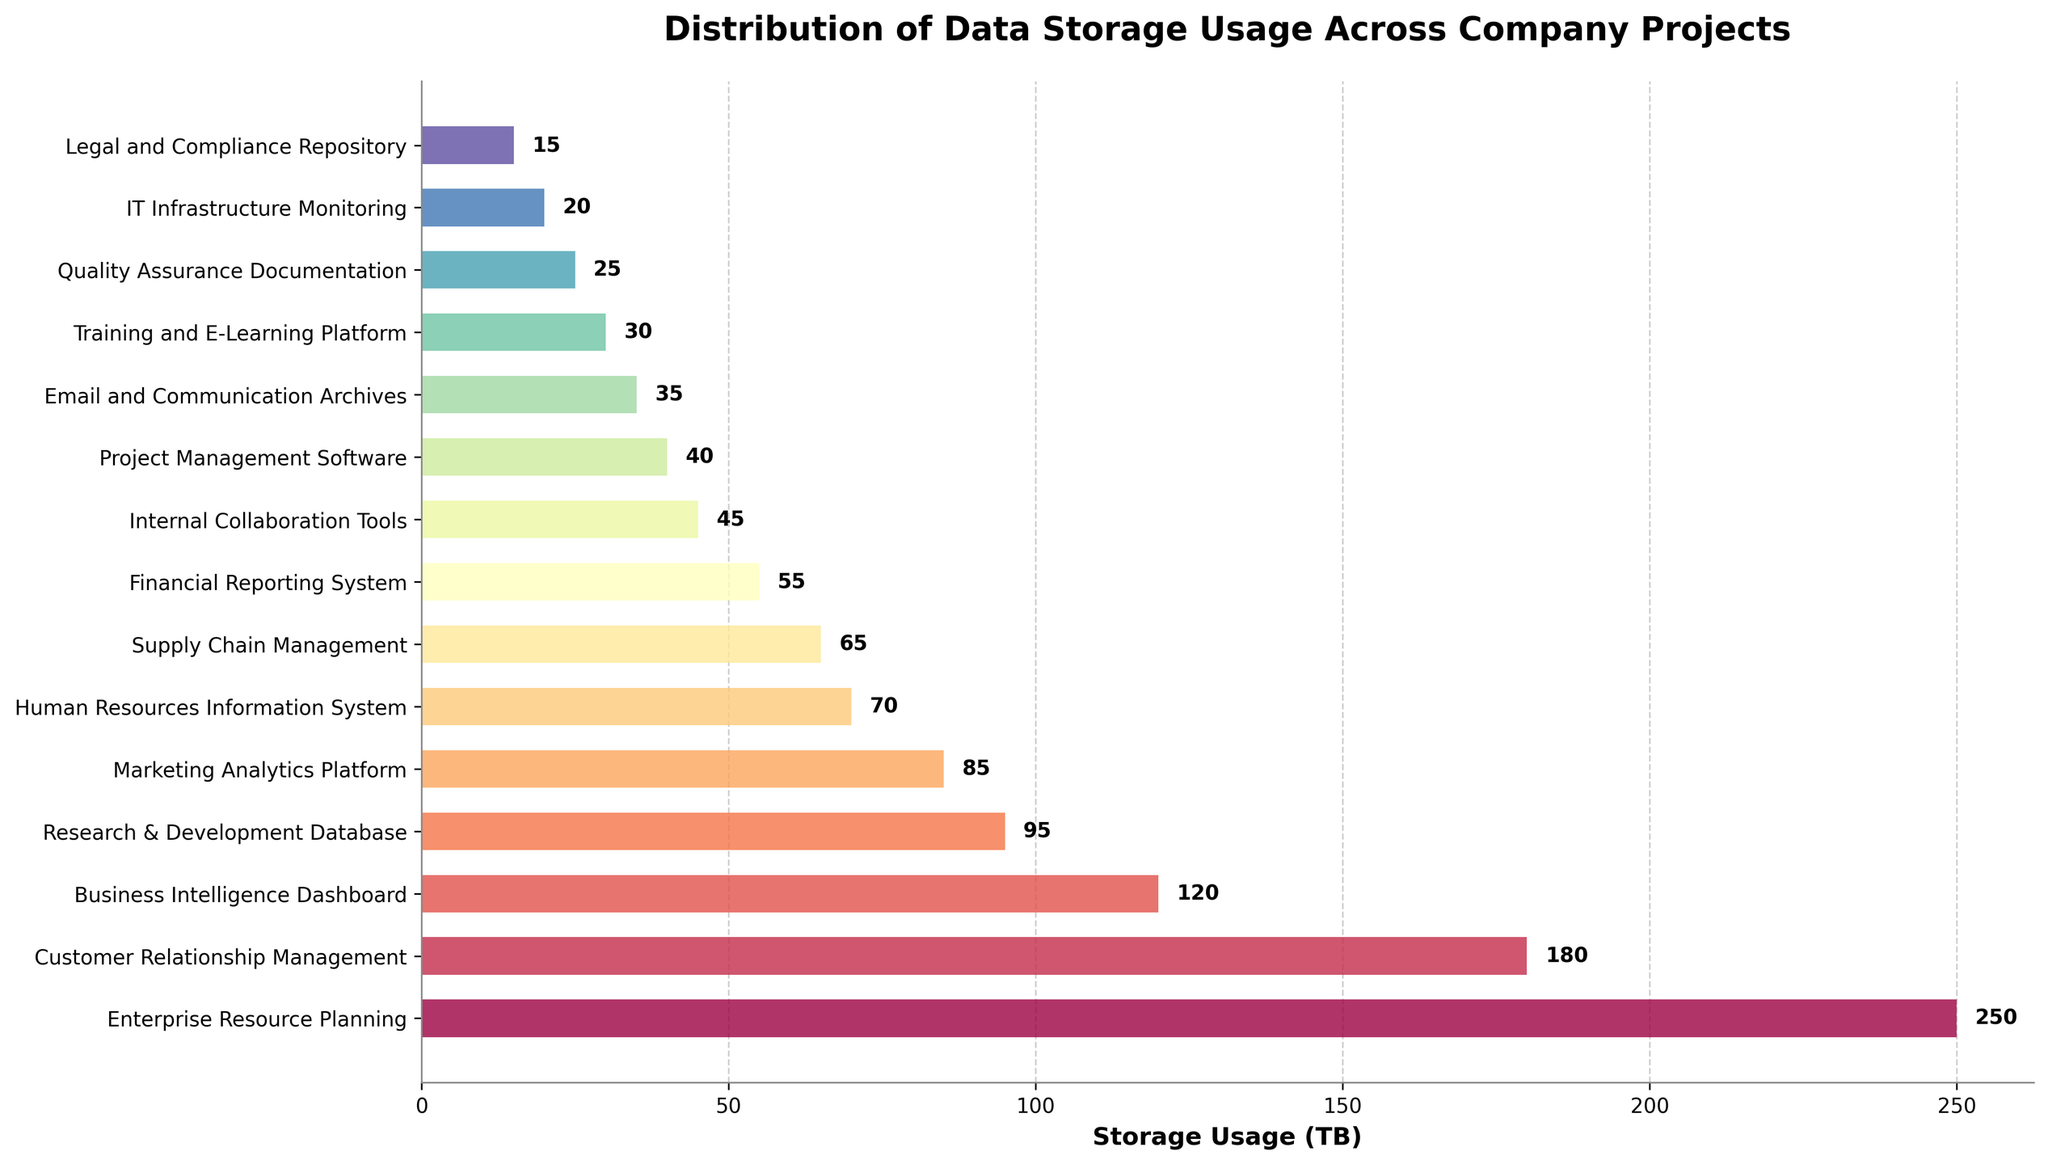Which project uses the most storage? Look for the tallest bar in the horizontal bar chart. The tallest bar represents the project with the highest storage usage, which is "Enterprise Resource Planning" at 250 TB.
Answer: Enterprise Resource Planning Which project uses less storage: Internal Collaboration Tools or Training and E-Learning Platform? Compare the lengths of the bars corresponding to "Internal Collaboration Tools" and "Training and E-Learning Platform". The bar for "Internal Collaboration Tools" is longer (45 TB) compared to the bar for "Training and E-Learning Platform" (30 TB).
Answer: Training and E-Learning Platform What is the combined storage usage of the top three projects by storage? Identify the top three longest bars, which correspond to "Enterprise Resource Planning" (250 TB), "Customer Relationship Management" (180 TB), and "Business Intelligence Dashboard" (120 TB). Sum these values: 250 + 180 + 120 = 550 TB.
Answer: 550 TB Which project has the least storage usage, and what is the value? Look for the shortest bar in the horizontal bar chart. The shortest bar represents the project with the lowest storage usage, which is the "Legal and Compliance Repository" at 15 TB.
Answer: Legal and Compliance Repository, 15 TB Are there any projects that have equal storage usage? Review the chart to see if any bars have the same length. None of the bars have the exact same length, indicating no projects have equal storage usage.
Answer: No What is the average storage usage across all projects? Sum the storage usage values for all the projects: 250 (ERP) + 180 (CRM) + 120 (BI Dashboard) + 95 (R&D DB) + 85 (Marketing Analytics) + 70 (HRIS) + 65 (Supply Chain Management) + 55 (Financial Reporting) + 45 (Internal Collaboration) + 40 (Project Management) + 35 (Email Archives) + 30 (Training & E-Learning) + 25 (QA Documentation) + 20 (IT Monitoring) + 15 (Legal and Compliance) = 1130 TB. Divide this by the number of projects: 1130 / 15 ≈ 75.33 TB.
Answer: 75.33 TB Which three projects use the least storage, and what is their combined storage usage? Identify the three shortest bars corresponding to "Legal and Compliance Repository" (15 TB), "IT Infrastructure Monitoring" (20 TB), and "Quality Assurance Documentation" (25 TB). Sum these values: 15 + 20 + 25 = 60 TB.
Answer: Legal and Compliance Repository, IT Infrastructure Monitoring, Quality Assurance Documentation; 60 TB How much more storage does the Enterprise Resource Planning project use compared to the Human Resources Information System? The storage usage for "Enterprise Resource Planning" is 250 TB, and for "Human Resources Information System" is 70 TB. Calculate the difference: 250 - 70 = 180 TB.
Answer: 180 TB Which project uses 85 TB of storage? Look for the bar that corresponds to the 85 TB mark. The "Marketing Analytics Platform" project uses 85 TB of storage.
Answer: Marketing Analytics Platform 